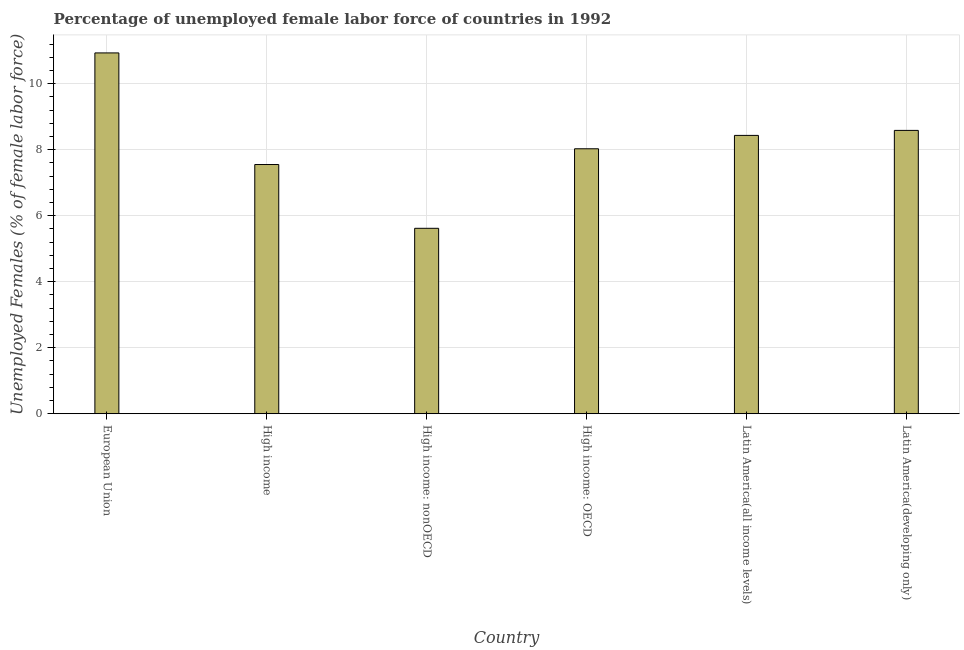Does the graph contain grids?
Make the answer very short. Yes. What is the title of the graph?
Make the answer very short. Percentage of unemployed female labor force of countries in 1992. What is the label or title of the X-axis?
Keep it short and to the point. Country. What is the label or title of the Y-axis?
Your response must be concise. Unemployed Females (% of female labor force). What is the total unemployed female labour force in High income?
Keep it short and to the point. 7.55. Across all countries, what is the maximum total unemployed female labour force?
Make the answer very short. 10.93. Across all countries, what is the minimum total unemployed female labour force?
Provide a short and direct response. 5.62. In which country was the total unemployed female labour force minimum?
Make the answer very short. High income: nonOECD. What is the sum of the total unemployed female labour force?
Provide a short and direct response. 49.14. What is the difference between the total unemployed female labour force in Latin America(all income levels) and Latin America(developing only)?
Your answer should be compact. -0.15. What is the average total unemployed female labour force per country?
Your response must be concise. 8.19. What is the median total unemployed female labour force?
Your response must be concise. 8.23. What is the ratio of the total unemployed female labour force in High income to that in Latin America(developing only)?
Offer a terse response. 0.88. Is the total unemployed female labour force in High income: nonOECD less than that in Latin America(all income levels)?
Ensure brevity in your answer.  Yes. What is the difference between the highest and the second highest total unemployed female labour force?
Offer a very short reply. 2.35. Is the sum of the total unemployed female labour force in High income and Latin America(all income levels) greater than the maximum total unemployed female labour force across all countries?
Give a very brief answer. Yes. What is the difference between the highest and the lowest total unemployed female labour force?
Provide a short and direct response. 5.31. How many countries are there in the graph?
Make the answer very short. 6. What is the difference between two consecutive major ticks on the Y-axis?
Provide a succinct answer. 2. What is the Unemployed Females (% of female labor force) of European Union?
Provide a succinct answer. 10.93. What is the Unemployed Females (% of female labor force) of High income?
Offer a very short reply. 7.55. What is the Unemployed Females (% of female labor force) in High income: nonOECD?
Offer a terse response. 5.62. What is the Unemployed Females (% of female labor force) of High income: OECD?
Make the answer very short. 8.03. What is the Unemployed Females (% of female labor force) of Latin America(all income levels)?
Provide a short and direct response. 8.43. What is the Unemployed Females (% of female labor force) in Latin America(developing only)?
Give a very brief answer. 8.58. What is the difference between the Unemployed Females (% of female labor force) in European Union and High income?
Provide a succinct answer. 3.38. What is the difference between the Unemployed Females (% of female labor force) in European Union and High income: nonOECD?
Keep it short and to the point. 5.31. What is the difference between the Unemployed Females (% of female labor force) in European Union and High income: OECD?
Ensure brevity in your answer.  2.9. What is the difference between the Unemployed Females (% of female labor force) in European Union and Latin America(all income levels)?
Offer a terse response. 2.5. What is the difference between the Unemployed Females (% of female labor force) in European Union and Latin America(developing only)?
Provide a short and direct response. 2.35. What is the difference between the Unemployed Females (% of female labor force) in High income and High income: nonOECD?
Provide a succinct answer. 1.93. What is the difference between the Unemployed Females (% of female labor force) in High income and High income: OECD?
Provide a succinct answer. -0.48. What is the difference between the Unemployed Females (% of female labor force) in High income and Latin America(all income levels)?
Give a very brief answer. -0.88. What is the difference between the Unemployed Females (% of female labor force) in High income and Latin America(developing only)?
Offer a very short reply. -1.03. What is the difference between the Unemployed Females (% of female labor force) in High income: nonOECD and High income: OECD?
Give a very brief answer. -2.41. What is the difference between the Unemployed Females (% of female labor force) in High income: nonOECD and Latin America(all income levels)?
Offer a very short reply. -2.81. What is the difference between the Unemployed Females (% of female labor force) in High income: nonOECD and Latin America(developing only)?
Ensure brevity in your answer.  -2.97. What is the difference between the Unemployed Females (% of female labor force) in High income: OECD and Latin America(all income levels)?
Your answer should be compact. -0.41. What is the difference between the Unemployed Females (% of female labor force) in High income: OECD and Latin America(developing only)?
Offer a terse response. -0.56. What is the difference between the Unemployed Females (% of female labor force) in Latin America(all income levels) and Latin America(developing only)?
Your answer should be compact. -0.15. What is the ratio of the Unemployed Females (% of female labor force) in European Union to that in High income?
Your answer should be compact. 1.45. What is the ratio of the Unemployed Females (% of female labor force) in European Union to that in High income: nonOECD?
Your response must be concise. 1.95. What is the ratio of the Unemployed Females (% of female labor force) in European Union to that in High income: OECD?
Give a very brief answer. 1.36. What is the ratio of the Unemployed Females (% of female labor force) in European Union to that in Latin America(all income levels)?
Offer a very short reply. 1.3. What is the ratio of the Unemployed Females (% of female labor force) in European Union to that in Latin America(developing only)?
Give a very brief answer. 1.27. What is the ratio of the Unemployed Females (% of female labor force) in High income to that in High income: nonOECD?
Offer a terse response. 1.34. What is the ratio of the Unemployed Females (% of female labor force) in High income to that in High income: OECD?
Provide a succinct answer. 0.94. What is the ratio of the Unemployed Females (% of female labor force) in High income to that in Latin America(all income levels)?
Offer a terse response. 0.9. What is the ratio of the Unemployed Females (% of female labor force) in High income to that in Latin America(developing only)?
Provide a short and direct response. 0.88. What is the ratio of the Unemployed Females (% of female labor force) in High income: nonOECD to that in High income: OECD?
Give a very brief answer. 0.7. What is the ratio of the Unemployed Females (% of female labor force) in High income: nonOECD to that in Latin America(all income levels)?
Your answer should be compact. 0.67. What is the ratio of the Unemployed Females (% of female labor force) in High income: nonOECD to that in Latin America(developing only)?
Make the answer very short. 0.65. What is the ratio of the Unemployed Females (% of female labor force) in High income: OECD to that in Latin America(all income levels)?
Your response must be concise. 0.95. What is the ratio of the Unemployed Females (% of female labor force) in High income: OECD to that in Latin America(developing only)?
Your response must be concise. 0.94. What is the ratio of the Unemployed Females (% of female labor force) in Latin America(all income levels) to that in Latin America(developing only)?
Make the answer very short. 0.98. 